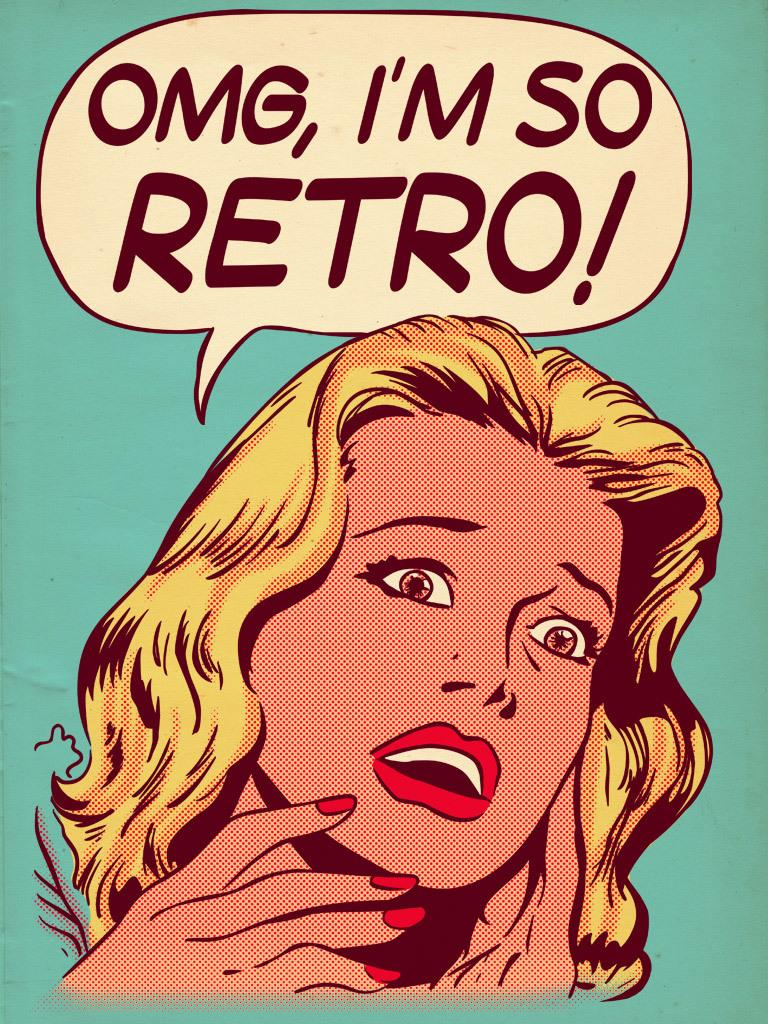What is present in the image that features an image and text? There is a poster in the image that contains an image and text. What type of image is on the poster? The poster contains an image of a woman. Can you describe the text on the poster? Unfortunately, the specific content of the text cannot be determined from the provided facts. What type of flowers are depicted in the image? There are no flowers present in the image; it features a poster with an image of a woman and text. What advice is given by the woman in the image? There is no indication in the image that the woman is giving advice, as the specific content of the text cannot be determined from the provided facts. 